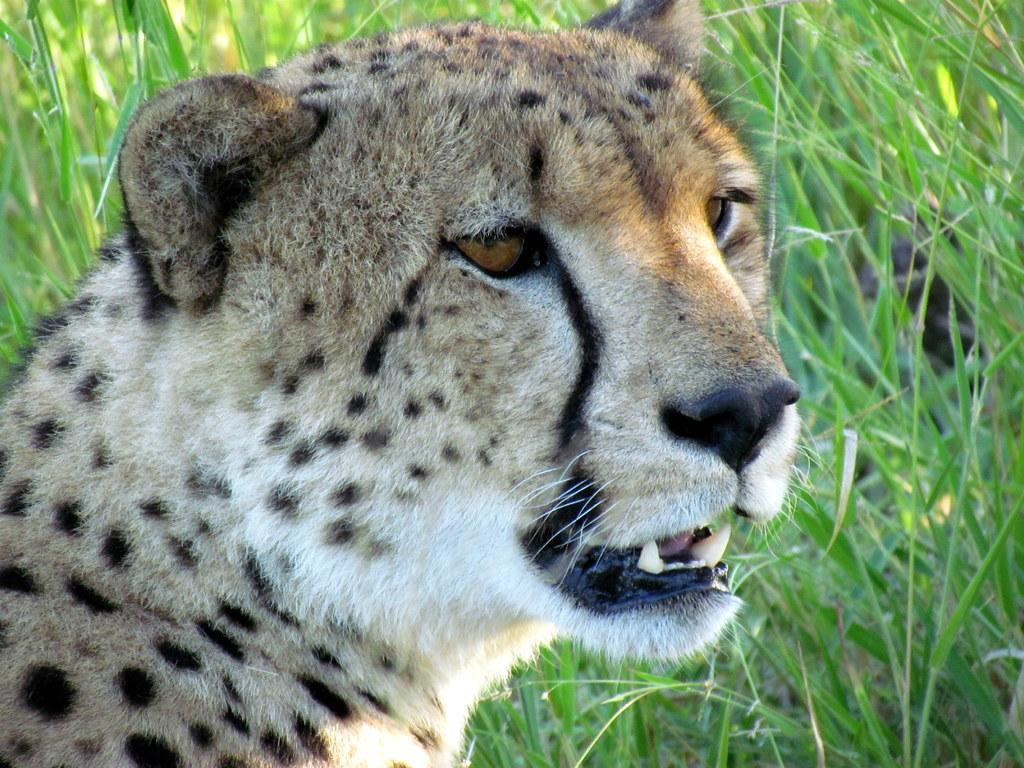What animal is present in the image? There is a cheetah in the image. What type of environment can be seen in the background of the image? There is grass visible in the background of the image. How many boots can be seen in the image? There are no boots present in the image. Are there any snakes visible in the image? There are no snakes visible in the image. 